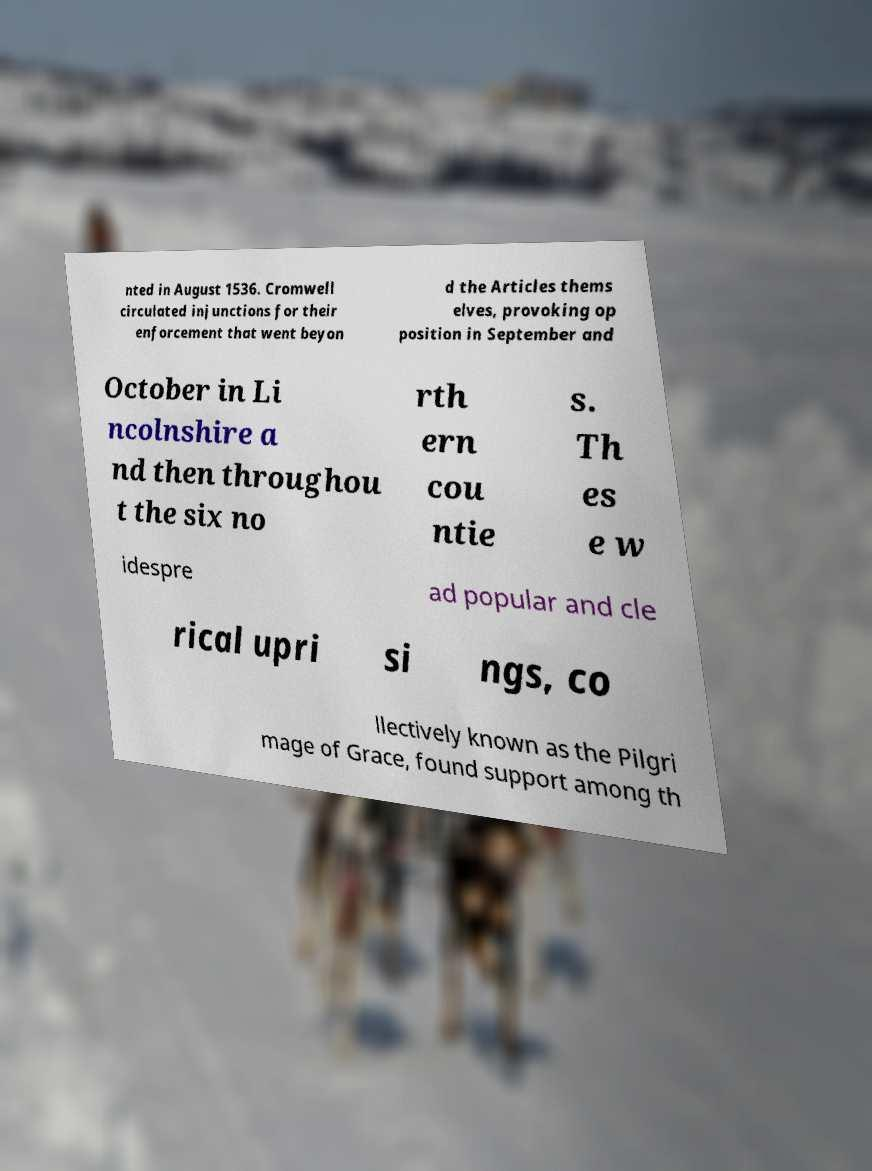For documentation purposes, I need the text within this image transcribed. Could you provide that? nted in August 1536. Cromwell circulated injunctions for their enforcement that went beyon d the Articles thems elves, provoking op position in September and October in Li ncolnshire a nd then throughou t the six no rth ern cou ntie s. Th es e w idespre ad popular and cle rical upri si ngs, co llectively known as the Pilgri mage of Grace, found support among th 